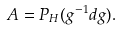<formula> <loc_0><loc_0><loc_500><loc_500>A = P _ { H } ( g ^ { - 1 } d g ) .</formula> 